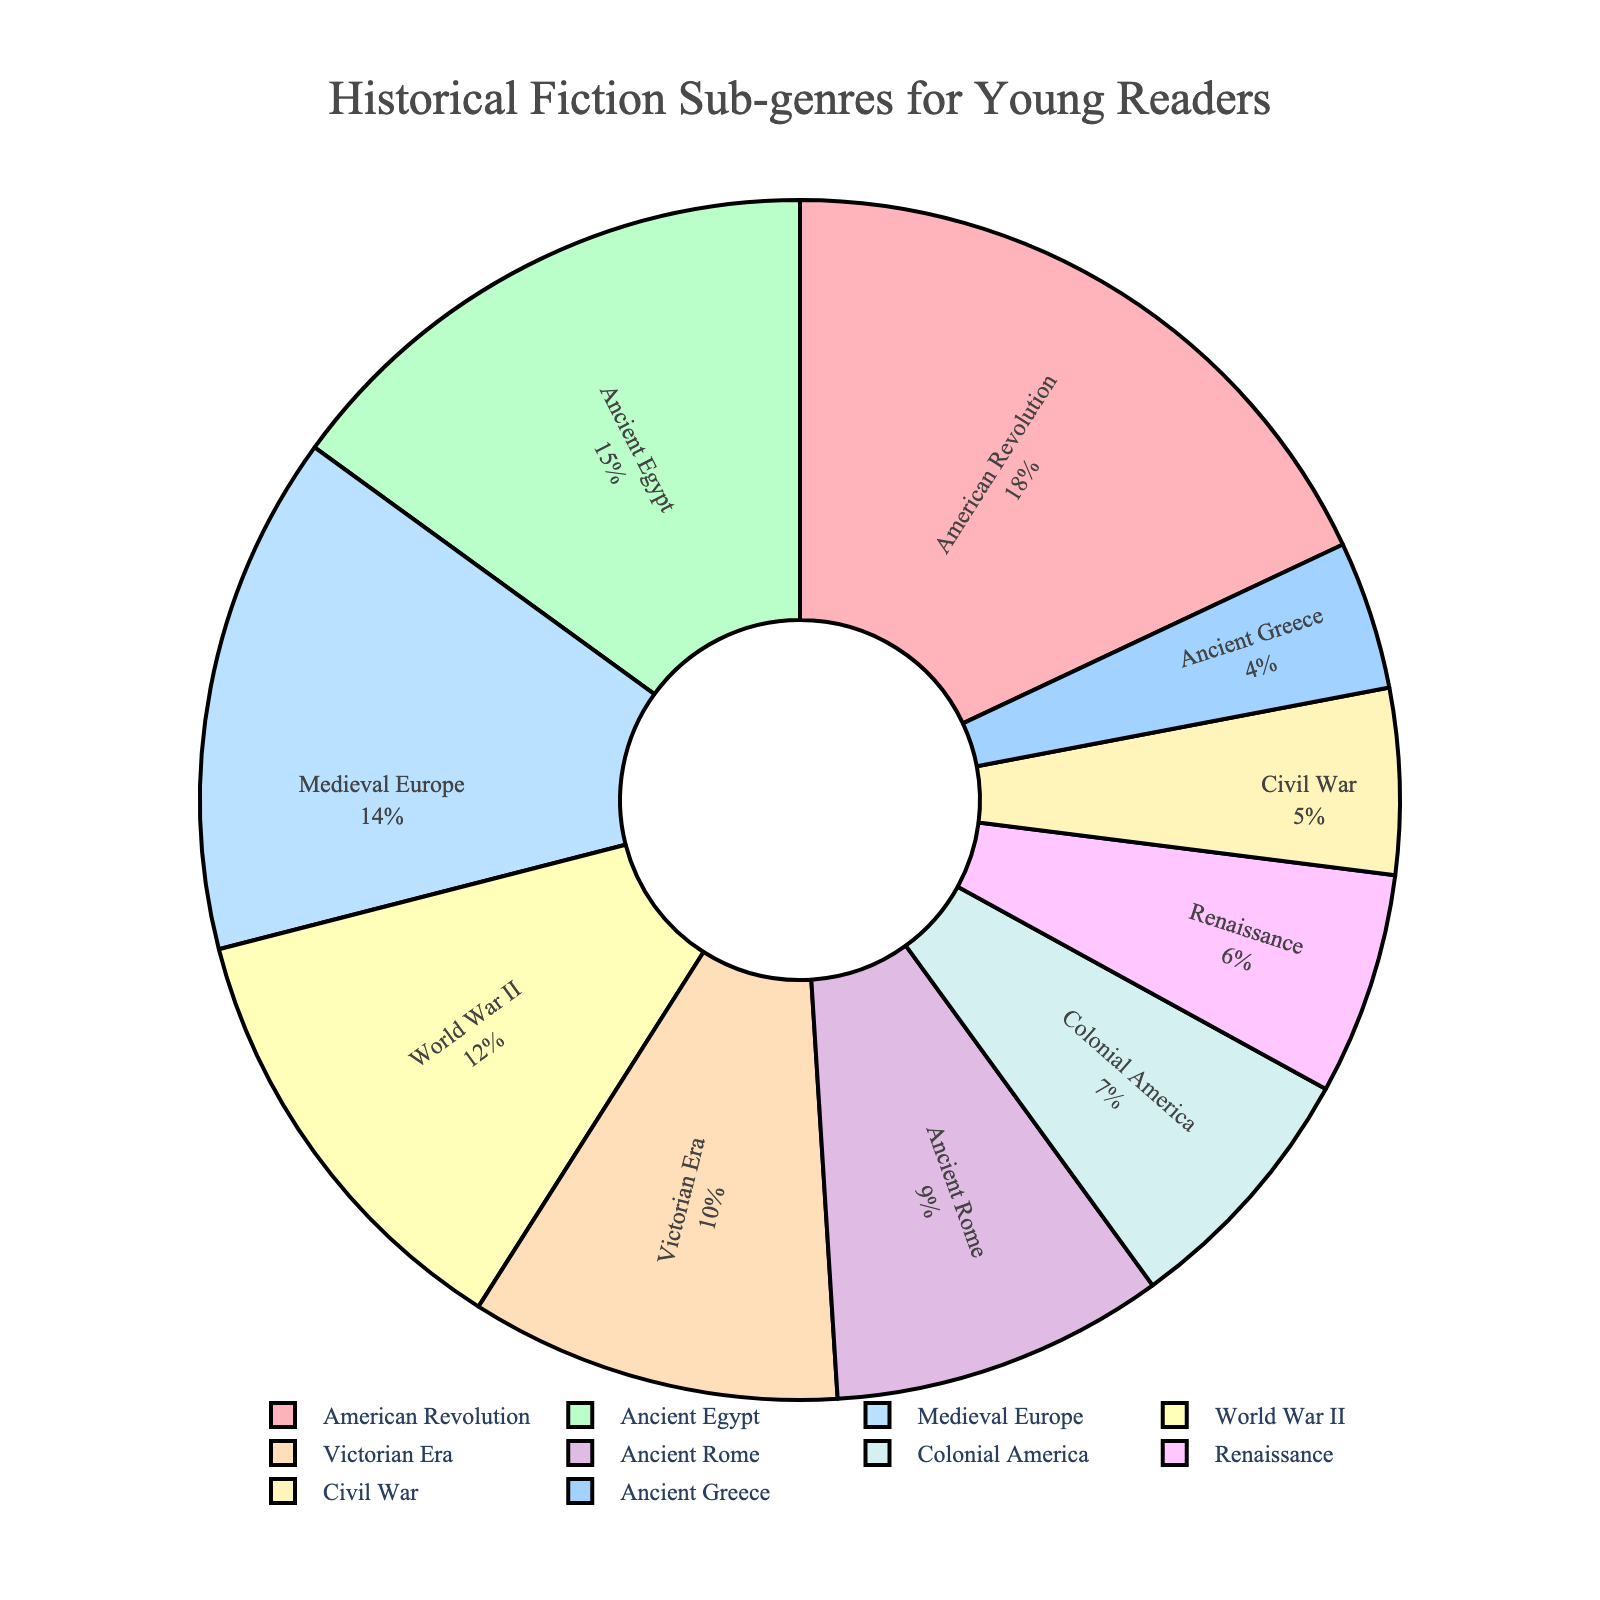Which sub-genre has the highest percentage of book sales? The sub-genre with the largest portion of the pie chart is the one with the highest percentage. In this chart, the "American Revolution" slice is the largest.
Answer: American Revolution How much greater is the percentage of "World War II" books compared to "Civil War" books? Find the "World War II" percentage and the "Civil War" percentage from the chart. Subtract the "Civil War" percentage from the "World War II" percentage: 12% - 5% = 7%.
Answer: 7% Which two sub-genres together account for 30% of book sales? Find two slices that together sum up to 30%. The slices for "American Revolution" and "Medieval Europe" together make 18% + 14% = 32%, which is closest to 30%. Alternatively, closer pairs must be tested, but this is the apparent answer.
Answer: American Revolution and Medieval Europe What's the difference in percentage between "Ancient Egypt" and "Victorian Era"? Find the percentages for "Ancient Egypt" and "Victorian Era" and subtract one from the other: 15% - 10% = 5%.
Answer: 5% Which sub-genre has the smallest percentage of book sales? The smallest slice of the pie chart will correspond to the smallest percentage. In this chart, the "Ancient Greece" slice is the smallest.
Answer: Ancient Greece How many sub-genres have a percentage of 10% or more? Count the number of slices with percentages of 10% or more. The sub-genres "American Revolution", "Ancient Egypt", "Medieval Europe", and "World War II" fit this criterion (4 slices total).
Answer: 4 What is the combined percentage of "Colonial America" and "Renaissance"? Add the percentages of "Colonial America" and "Renaissance". From the chart, that is: 7% + 6% = 13%.
Answer: 13% Between "Ancient Rome" and "Ancient Greece", which has a higher percentage? Compare the percentages of "Ancient Rome" and "Ancient Greece" from the chart. "Ancient Rome" has 9% and "Ancient Greece" has 4%.
Answer: Ancient Rome 